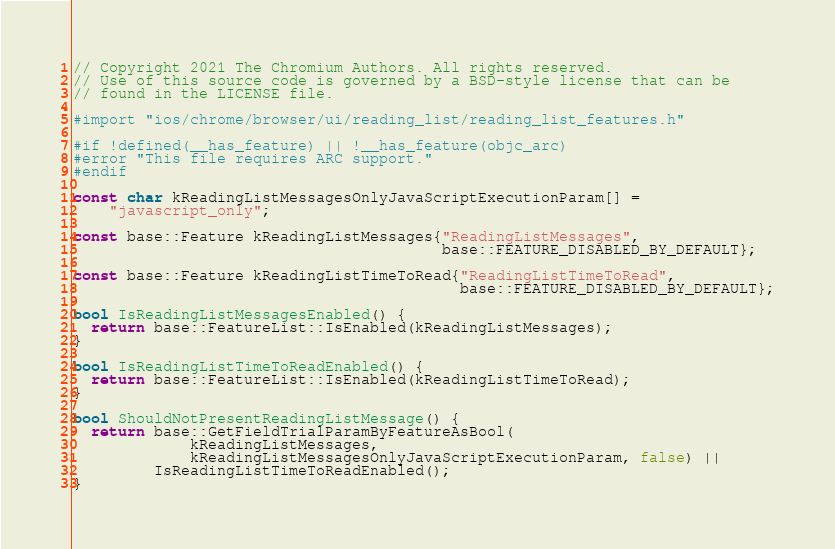Convert code to text. <code><loc_0><loc_0><loc_500><loc_500><_ObjectiveC_>// Copyright 2021 The Chromium Authors. All rights reserved.
// Use of this source code is governed by a BSD-style license that can be
// found in the LICENSE file.

#import "ios/chrome/browser/ui/reading_list/reading_list_features.h"

#if !defined(__has_feature) || !__has_feature(objc_arc)
#error "This file requires ARC support."
#endif

const char kReadingListMessagesOnlyJavaScriptExecutionParam[] =
    "javascript_only";

const base::Feature kReadingListMessages{"ReadingListMessages",
                                         base::FEATURE_DISABLED_BY_DEFAULT};

const base::Feature kReadingListTimeToRead{"ReadingListTimeToRead",
                                           base::FEATURE_DISABLED_BY_DEFAULT};

bool IsReadingListMessagesEnabled() {
  return base::FeatureList::IsEnabled(kReadingListMessages);
}

bool IsReadingListTimeToReadEnabled() {
  return base::FeatureList::IsEnabled(kReadingListTimeToRead);
}

bool ShouldNotPresentReadingListMessage() {
  return base::GetFieldTrialParamByFeatureAsBool(
             kReadingListMessages,
             kReadingListMessagesOnlyJavaScriptExecutionParam, false) ||
         IsReadingListTimeToReadEnabled();
}
</code> 